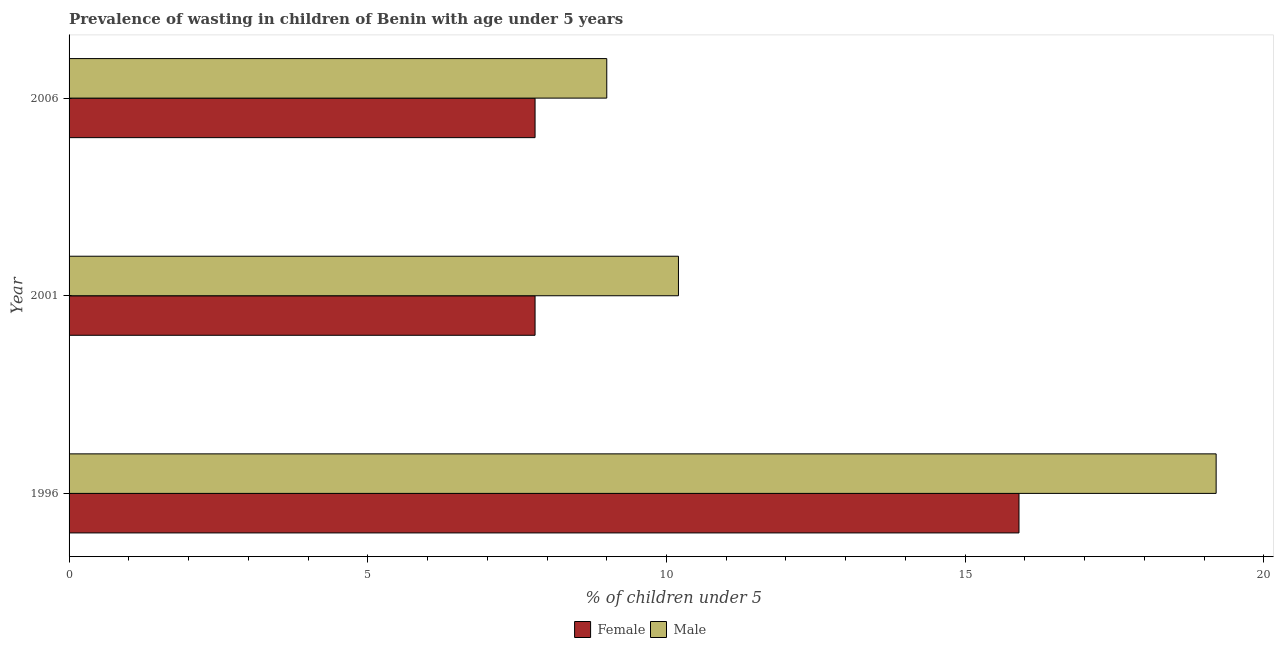How many groups of bars are there?
Offer a very short reply. 3. Are the number of bars per tick equal to the number of legend labels?
Ensure brevity in your answer.  Yes. Are the number of bars on each tick of the Y-axis equal?
Your response must be concise. Yes. How many bars are there on the 1st tick from the top?
Give a very brief answer. 2. What is the percentage of undernourished male children in 1996?
Offer a very short reply. 19.2. Across all years, what is the maximum percentage of undernourished male children?
Make the answer very short. 19.2. Across all years, what is the minimum percentage of undernourished male children?
Provide a succinct answer. 9. In which year was the percentage of undernourished male children maximum?
Provide a succinct answer. 1996. In which year was the percentage of undernourished female children minimum?
Keep it short and to the point. 2001. What is the total percentage of undernourished female children in the graph?
Offer a terse response. 31.5. What is the difference between the percentage of undernourished male children in 1996 and the percentage of undernourished female children in 2006?
Provide a succinct answer. 11.4. What is the average percentage of undernourished male children per year?
Your response must be concise. 12.8. In how many years, is the percentage of undernourished male children greater than 10 %?
Offer a very short reply. 2. What is the ratio of the percentage of undernourished male children in 2001 to that in 2006?
Offer a very short reply. 1.13. What is the difference between the highest and the second highest percentage of undernourished male children?
Give a very brief answer. 9. Is the sum of the percentage of undernourished male children in 1996 and 2001 greater than the maximum percentage of undernourished female children across all years?
Provide a succinct answer. Yes. Are all the bars in the graph horizontal?
Provide a short and direct response. Yes. What is the difference between two consecutive major ticks on the X-axis?
Offer a very short reply. 5. Does the graph contain grids?
Ensure brevity in your answer.  No. How many legend labels are there?
Provide a succinct answer. 2. How are the legend labels stacked?
Your answer should be compact. Horizontal. What is the title of the graph?
Provide a short and direct response. Prevalence of wasting in children of Benin with age under 5 years. What is the label or title of the X-axis?
Provide a succinct answer.  % of children under 5. What is the label or title of the Y-axis?
Keep it short and to the point. Year. What is the  % of children under 5 of Female in 1996?
Give a very brief answer. 15.9. What is the  % of children under 5 of Male in 1996?
Ensure brevity in your answer.  19.2. What is the  % of children under 5 in Female in 2001?
Your answer should be very brief. 7.8. What is the  % of children under 5 of Male in 2001?
Offer a terse response. 10.2. What is the  % of children under 5 in Female in 2006?
Offer a very short reply. 7.8. Across all years, what is the maximum  % of children under 5 in Female?
Keep it short and to the point. 15.9. Across all years, what is the maximum  % of children under 5 in Male?
Your answer should be very brief. 19.2. Across all years, what is the minimum  % of children under 5 in Female?
Offer a terse response. 7.8. What is the total  % of children under 5 of Female in the graph?
Ensure brevity in your answer.  31.5. What is the total  % of children under 5 of Male in the graph?
Give a very brief answer. 38.4. What is the difference between the  % of children under 5 in Female in 1996 and that in 2006?
Offer a terse response. 8.1. What is the difference between the  % of children under 5 of Female in 2001 and that in 2006?
Your answer should be compact. 0. What is the difference between the  % of children under 5 in Female in 2001 and the  % of children under 5 in Male in 2006?
Keep it short and to the point. -1.2. What is the average  % of children under 5 of Female per year?
Provide a short and direct response. 10.5. In the year 2001, what is the difference between the  % of children under 5 of Female and  % of children under 5 of Male?
Provide a succinct answer. -2.4. In the year 2006, what is the difference between the  % of children under 5 in Female and  % of children under 5 in Male?
Offer a very short reply. -1.2. What is the ratio of the  % of children under 5 of Female in 1996 to that in 2001?
Provide a short and direct response. 2.04. What is the ratio of the  % of children under 5 of Male in 1996 to that in 2001?
Your answer should be very brief. 1.88. What is the ratio of the  % of children under 5 of Female in 1996 to that in 2006?
Give a very brief answer. 2.04. What is the ratio of the  % of children under 5 in Male in 1996 to that in 2006?
Keep it short and to the point. 2.13. What is the ratio of the  % of children under 5 of Female in 2001 to that in 2006?
Your answer should be very brief. 1. What is the ratio of the  % of children under 5 of Male in 2001 to that in 2006?
Your answer should be very brief. 1.13. What is the difference between the highest and the second highest  % of children under 5 in Female?
Keep it short and to the point. 8.1. What is the difference between the highest and the second highest  % of children under 5 in Male?
Your answer should be very brief. 9. What is the difference between the highest and the lowest  % of children under 5 of Female?
Your answer should be very brief. 8.1. 